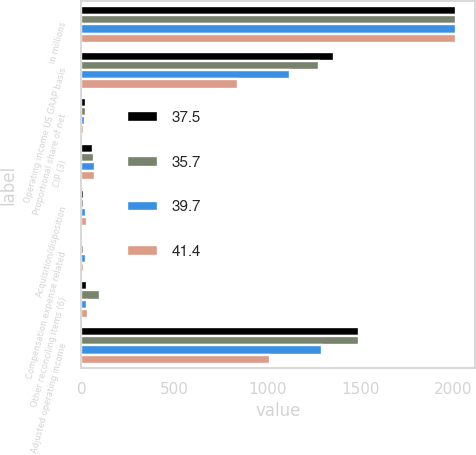<chart> <loc_0><loc_0><loc_500><loc_500><stacked_bar_chart><ecel><fcel>in millions<fcel>Operating income US GAAP basis<fcel>Proportional share of net<fcel>CIP (3)<fcel>Acquisition/disposition<fcel>Compensation expense related<fcel>Other reconciling items (6)<fcel>Adjusted operating income<nl><fcel>37.5<fcel>2015<fcel>1358.4<fcel>27.4<fcel>63.2<fcel>12.8<fcel>4.3<fcel>27.6<fcel>1493.7<nl><fcel>35.7<fcel>2014<fcel>1276.9<fcel>25.9<fcel>69.8<fcel>12.6<fcel>11.5<fcel>98.3<fcel>1495<nl><fcel>39.7<fcel>2013<fcel>1120.2<fcel>21.3<fcel>73<fcel>23<fcel>25.1<fcel>29.5<fcel>1292.1<nl><fcel>41.4<fcel>2012<fcel>842.6<fcel>15.7<fcel>72.5<fcel>31.4<fcel>14.3<fcel>35.6<fcel>1012.1<nl></chart> 